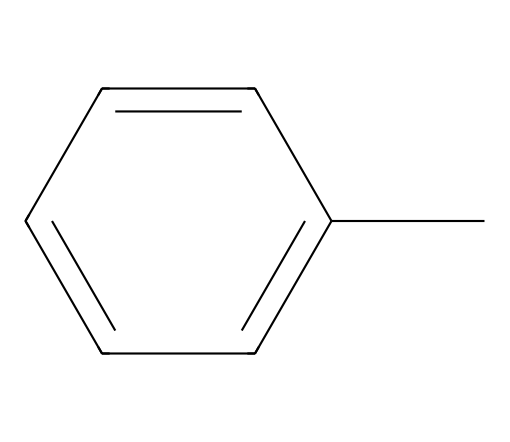What is the molecular formula of toluene? The SMILES representation indicates that toluene consists of one carbon atom attached to a benzene ring (which has six carbon atoms), giving a total of seven carbon atoms and eight hydrogen atoms. Therefore, the molecular formula can be derived as C7H8.
Answer: C7H8 How many hydrogen atoms are present in toluene? By examining the SMILES representation, we determine that each carbon atom needs hydrogen atoms to complete its four bonds. In the structure of toluene (C7H8), there are eight hydrogen atoms necessary to satisfy the bonding requirements of the seven carbon atoms.
Answer: 8 What type of bonding is primarily present in toluene? Toluene has a structure characterized by carbon-carbon bonds and carbon-hydrogen bonds. The carbon atoms in the benzene ring are linked by alternating single and double bonds, which signifies aromatic bonding, alongside typical single covalent bonds to hydrogen atoms.
Answer: covalent Is toluene considered a hazardous substance? Toluene is classified as a hazardous chemical due to its potential health risks, including neurological damage, respiratory issues, and skin irritation upon exposure. The hazardous nature stems from its volatility and ability to affect the central nervous system.
Answer: yes What type of hydrocarbon is represented by toluene? Toluene is an aromatic hydrocarbon, characterized by its inclusion of a benzene ring within its structure. Aromatic hydrocarbons have unique stability due to resonance and delocalization of electrons in the ring.
Answer: aromatic How many rings are present in the structure of toluene? The SMILES representation shows that toluene contains one benzene ring. A benzene ring is composed of six carbon atoms arranged in a cyclic structure, and in the case of toluene, it is connected to an additional carbon atom.
Answer: 1 What functional group is associated with toluene's structure? In toluene, the functional group associated with the structure is the methyl group (-CH3), which is the peripheral carbon atom connected to the benzene ring. This methyl group classifies toluene as a methyl-substituted aromatic compound.
Answer: methyl 